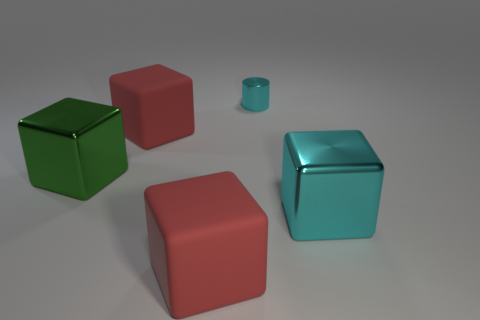Are there any indications of size or scale in this image? Without any familiar objects or reference points in the image to provide context, it's difficult to determine the exact size or scale of the objects. They may vary in size from small tabletop items to larger furniture-sized pieces. 